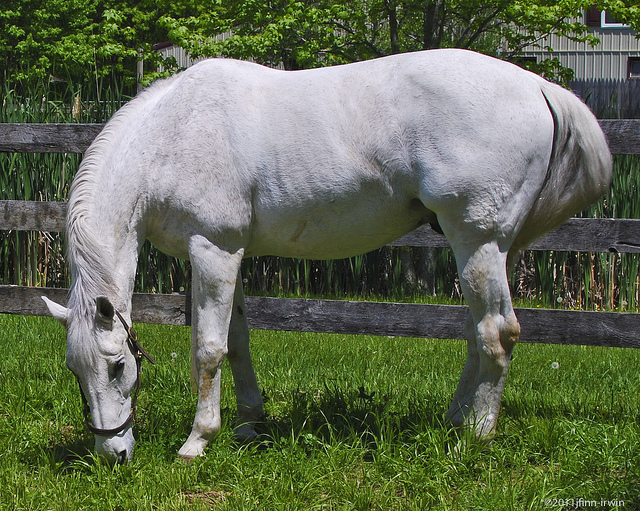If you were to add a whimsical element to the picture, what would it be? If I were to add a whimsical element to the picture, I would add a unicorn standing next to the horse. The unicorn, with its sparkling horn and rainbow-colored mane, would create a magical and fantastical atmosphere. The scene would look like something out of a fairy tale, with the tranquil pasture transformed into an enchanting woodland meadow. How do you think the presence of a rainbow in the sky would change the perception of this image? The presence of a rainbow in the sky would add a touch of magic and wonder to the image. It would enhance the serene and peaceful mood, making the scene feel even more picturesque and idyllic. A rainbow often symbolizes hope and beauty, so its inclusion would likely evoke positive emotions and a sense of awe from viewers. 